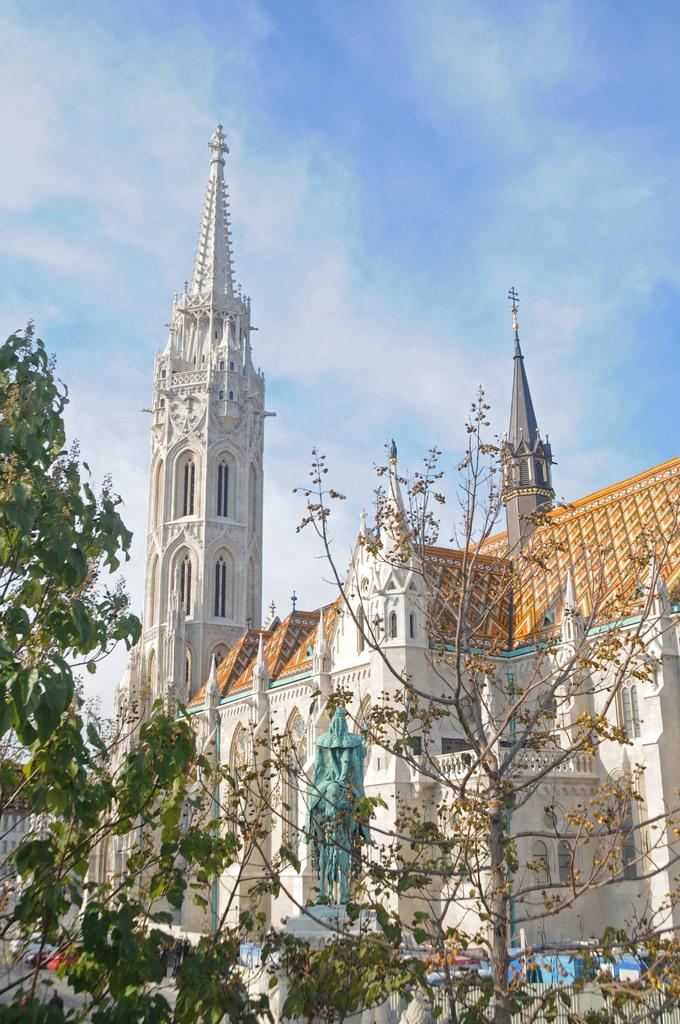What type of natural elements can be seen in the image? There are trees in the image. What man-made object is present in the image? There is a sculpture in the image. What type of structures can be seen in the image? A: There are buildings in the image. What is visible in the background of the image? The sky is visible in the background of the image. How many legs can be seen on the ducks in the image? There are no ducks present in the image, so it is not possible to determine the number of legs. 